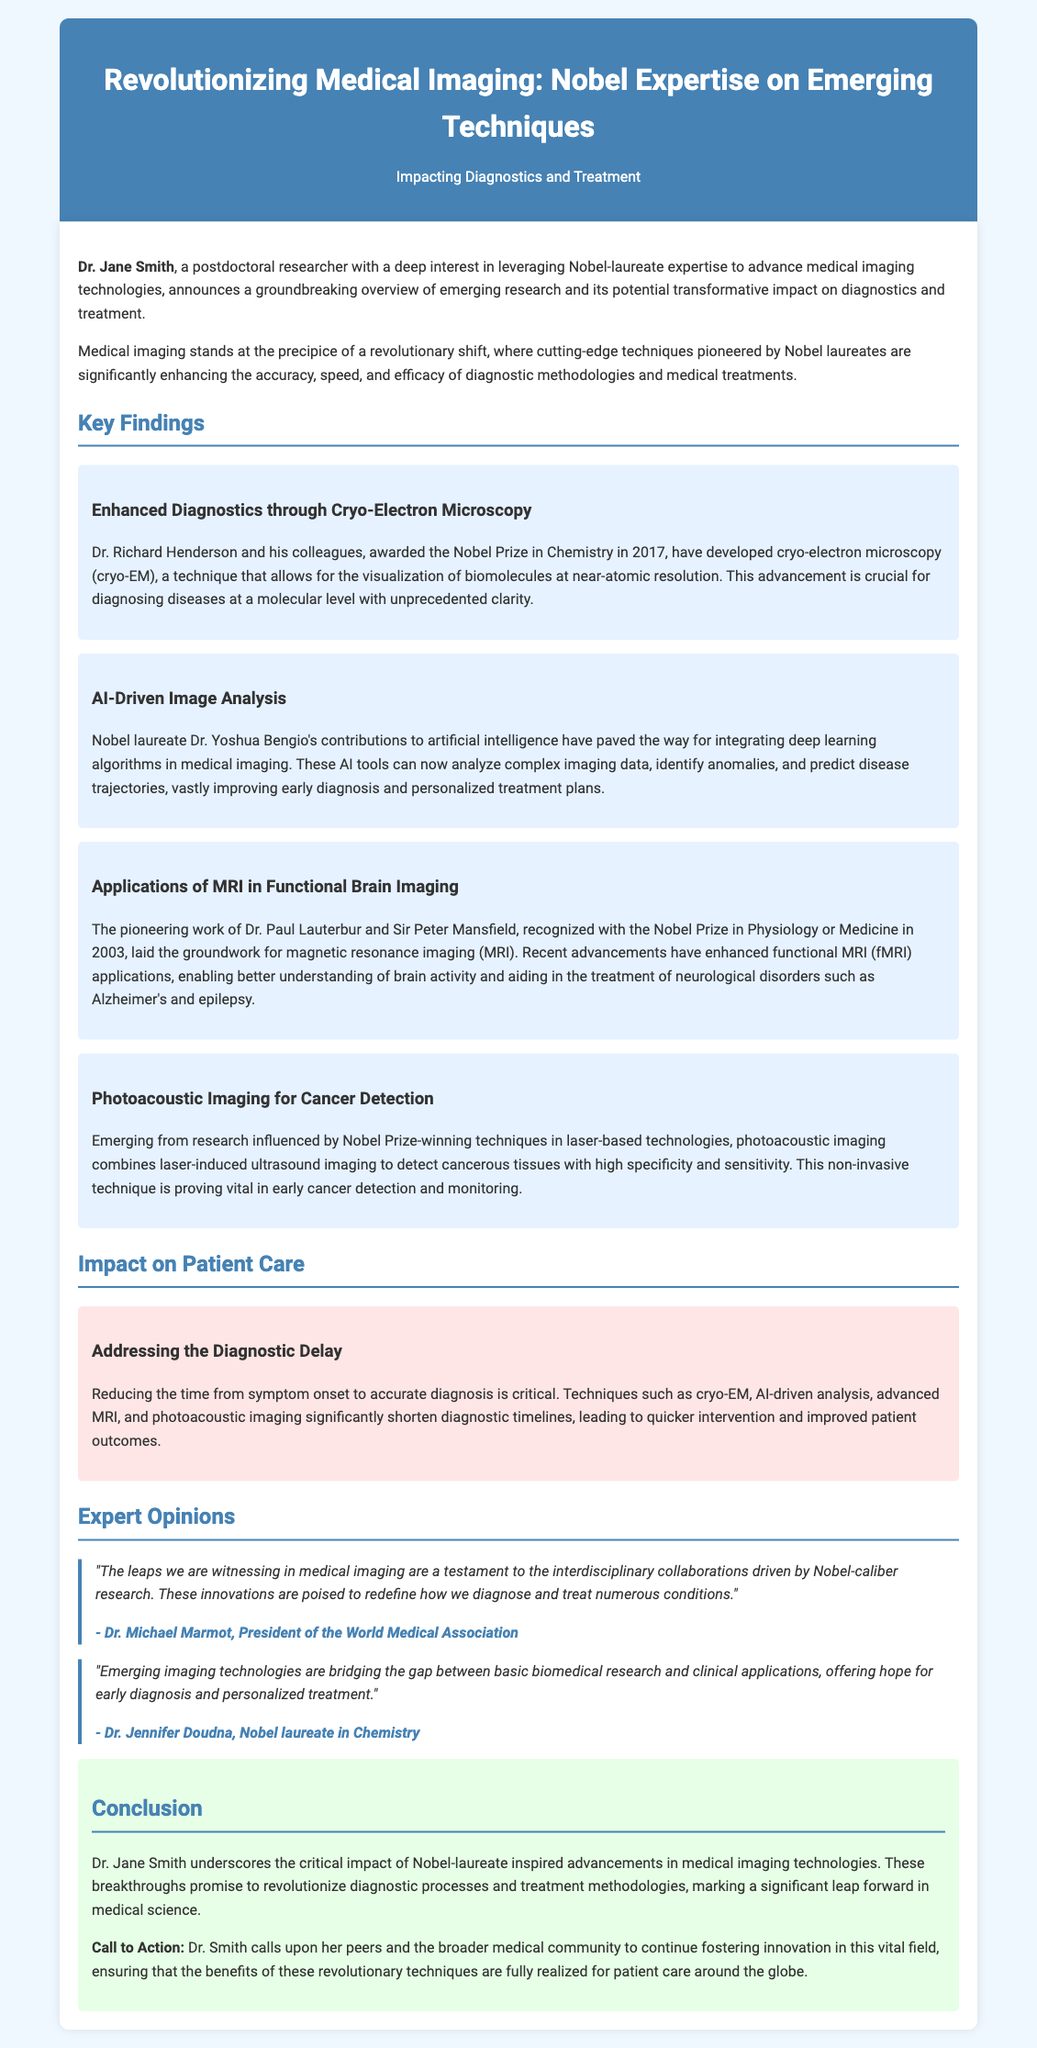What is the title of the press release? The title of the press release is stated at the beginning and is "Revolutionizing Medical Imaging: Nobel Expertise on Emerging Techniques".
Answer: Revolutionizing Medical Imaging: Nobel Expertise on Emerging Techniques Who is credited with developing cryo-electron microscopy? The document specifies that cryo-electron microscopy (cryo-EM) was developed by Dr. Richard Henderson and his colleagues.
Answer: Dr. Richard Henderson What prize did Dr. Yoshua Bengio win? The document mentions that Dr. Yoshua Bengio is a Nobel laureate, which implies he has won the Nobel Prize.
Answer: Nobel Prize What technology combines laser-induced ultrasound imaging for cancer detection? The document refers to photoacoustic imaging as a technology that combines laser-induced ultrasound imaging for cancer detection.
Answer: Photoacoustic imaging How does AI-driven analysis improve diagnostics? The text explains that AI-driven analysis identifies anomalies and predicts disease trajectories, enhancing early diagnosis and personalized treatment plans.
Answer: Identifies anomalies What significant issue do the emerging techniques address? The press release states that these techniques help reduce the time from symptom onset to accurate diagnosis.
Answer: Diagnostic Delay Who provided an expert opinion on the impact of the advancements in medical imaging? The document lists two expert opinions, one by Dr. Michael Marmot and another by Dr. Jennifer Doudna.
Answer: Dr. Michael Marmot What is the call to action issued by Dr. Jane Smith? The document details that Dr. Smith calls upon her peers to continue fostering innovation in medical imaging.
Answer: Foster innovation In what year did Dr. Paul Lauterbur and Sir Peter Mansfield win the Nobel Prize? The document indicates that they were recognized with the Nobel Prize in Physiology or Medicine in 2003.
Answer: 2003 